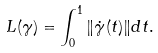Convert formula to latex. <formula><loc_0><loc_0><loc_500><loc_500>L ( \gamma ) = \int _ { 0 } ^ { 1 } \| \dot { \gamma } ( t ) \| d t .</formula> 